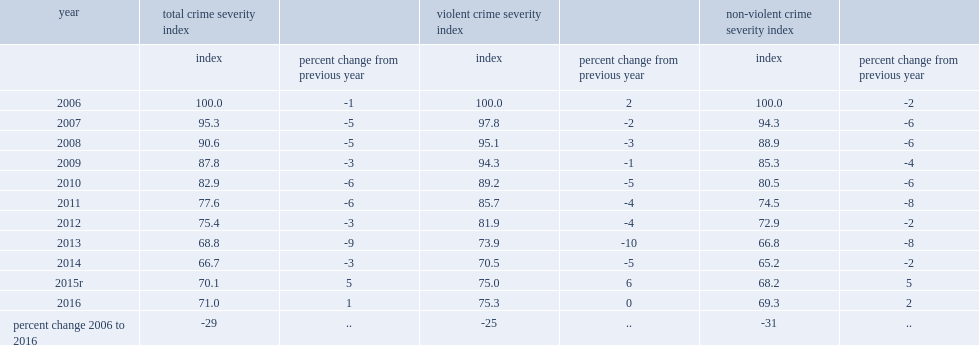What is the percentage of canada's non-violent crime severity index (csi) has increased in 2016? 2.0. Compare to 2015, what is the percentage of canada's csi has increased in 2016? 1.0. Compare to a decade before, what is the percentage of canada's csi has declined in 2016? 29. What is the percentage of canada's non-violent crime severity index (csi) has increased in 2016? 2.0. 